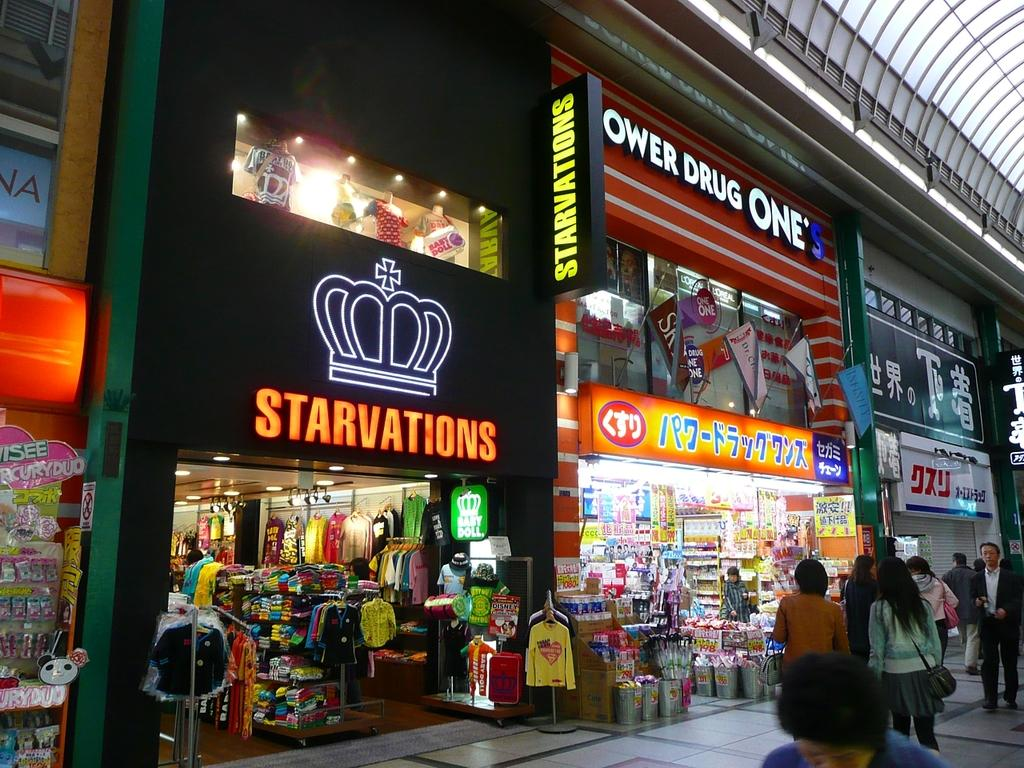<image>
Provide a brief description of the given image. People are walking through a shopping center that includes the Starvations clothing store. 